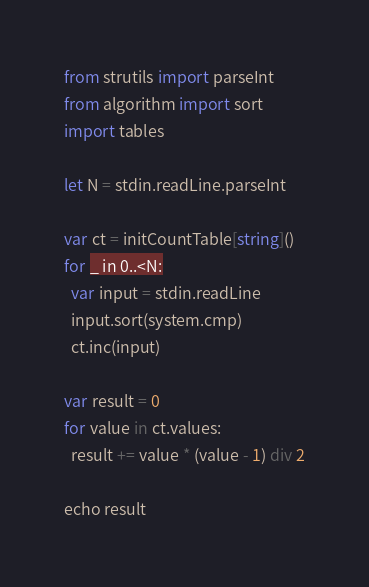<code> <loc_0><loc_0><loc_500><loc_500><_Nim_>from strutils import parseInt
from algorithm import sort
import tables

let N = stdin.readLine.parseInt

var ct = initCountTable[string]()
for _ in 0..<N:
  var input = stdin.readLine
  input.sort(system.cmp)
  ct.inc(input)

var result = 0
for value in ct.values:
  result += value * (value - 1) div 2

echo result
</code> 